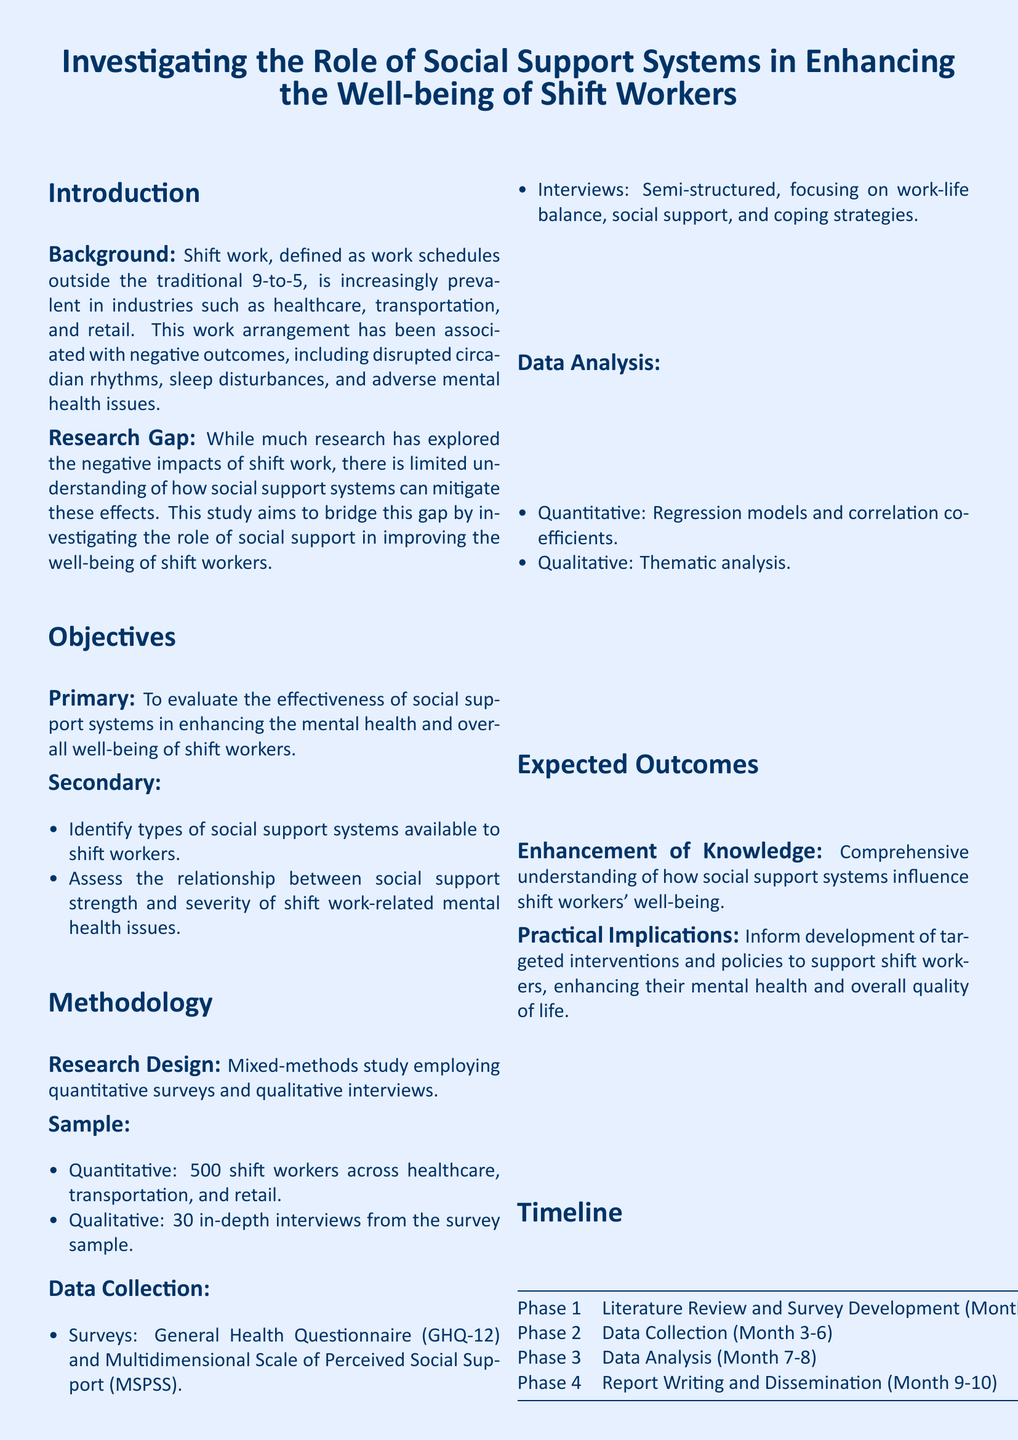What is the primary objective of the study? The primary objective is to evaluate the effectiveness of social support systems in enhancing the mental health and overall well-being of shift workers.
Answer: To evaluate the effectiveness of social support systems in enhancing the mental health and overall well-being of shift workers How many shift workers are included in the quantitative sample? The quantitative sample includes 500 shift workers across various industries.
Answer: 500 What qualitative method is used for data collection? The qualitative method used is semi-structured interviews focusing on specific topics related to social support and coping strategies.
Answer: Semi-structured interviews What are the expected outcomes of the research? The expected outcomes include a comprehensive understanding of social support systems and informing interventions for shift workers.
Answer: Comprehensive understanding of how social support systems influence shift workers' well-being In which month does the data analysis phase begin? The data analysis phase starts in Month 7 as outlined in the timeline section.
Answer: Month 7 What type of study design is employed in this research? The study employs a mixed-methods design, integrating both quantitative surveys and qualitative interviews.
Answer: Mixed-methods study Which health questionnaire is utilized for the quantitative data collection? The General Health Questionnaire (GHQ-12) is used for quantitative data collection.
Answer: General Health Questionnaire (GHQ-12) What is the duration of the entire research project? The entire research project lasts for approximately 10 months, as indicated in the timeline.
Answer: 10 months 